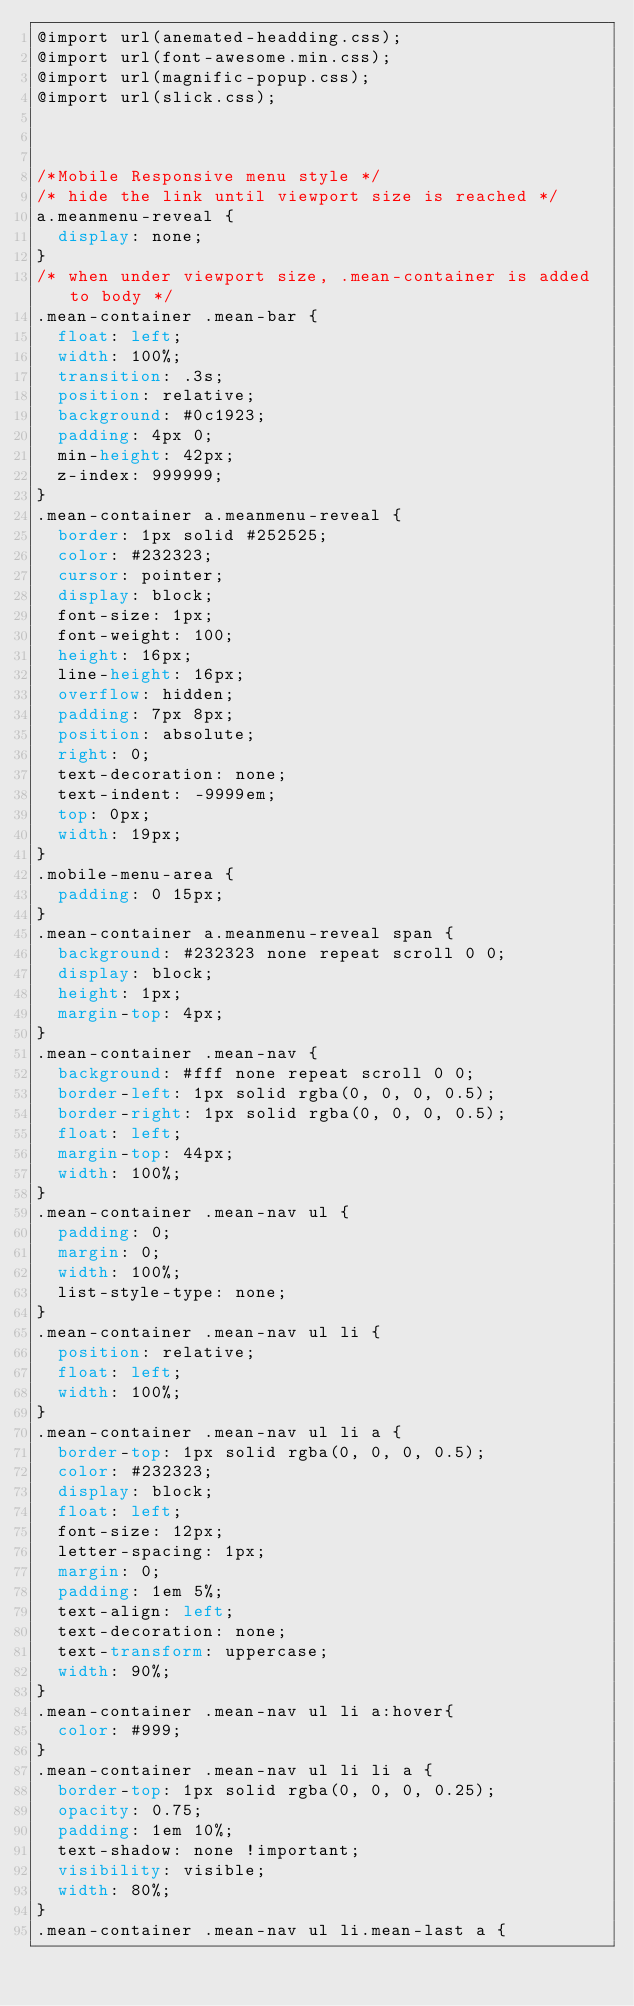Convert code to text. <code><loc_0><loc_0><loc_500><loc_500><_CSS_>@import url(anemated-headding.css);
@import url(font-awesome.min.css);
@import url(magnific-popup.css);
@import url(slick.css);



/*Mobile Responsive menu style */
/* hide the link until viewport size is reached */
a.meanmenu-reveal {
	display: none;
}
/* when under viewport size, .mean-container is added to body */
.mean-container .mean-bar {
	float: left;
	width: 100%;
	transition: .3s;
	position: relative;
	background: #0c1923;
	padding: 4px 0;
	min-height: 42px;
	z-index: 999999;
}
.mean-container a.meanmenu-reveal {
  border: 1px solid #252525;
  color: #232323;
  cursor: pointer;
  display: block;
  font-size: 1px;
  font-weight: 100;
  height: 16px;
  line-height: 16px;
  overflow: hidden;
  padding: 7px 8px;
  position: absolute;
  right: 0;
  text-decoration: none;
  text-indent: -9999em;
  top: 0px;
  width: 19px;
}
.mobile-menu-area {
	padding: 0 15px;
}
.mean-container a.meanmenu-reveal span {
  background: #232323 none repeat scroll 0 0;
  display: block;
  height: 1px;
  margin-top: 4px;
}
.mean-container .mean-nav {
  background: #fff none repeat scroll 0 0;
  border-left: 1px solid rgba(0, 0, 0, 0.5);
  border-right: 1px solid rgba(0, 0, 0, 0.5);
  float: left;
  margin-top: 44px;
  width: 100%;
}
.mean-container .mean-nav ul {
	padding: 0;
	margin: 0;
	width: 100%;
	list-style-type: none;
}
.mean-container .mean-nav ul li {
	position: relative;
	float: left;
	width: 100%;
}
.mean-container .mean-nav ul li a {
  border-top: 1px solid rgba(0, 0, 0, 0.5);
  color: #232323;
  display: block;
  float: left;
  font-size: 12px;
  letter-spacing: 1px;
  margin: 0;
  padding: 1em 5%;
  text-align: left;
  text-decoration: none;
  text-transform: uppercase;
  width: 90%;
}
.mean-container .mean-nav ul li a:hover{
	color: #999;
}
.mean-container .mean-nav ul li li a {
  border-top: 1px solid rgba(0, 0, 0, 0.25);
  opacity: 0.75;
  padding: 1em 10%;
  text-shadow: none !important;
  visibility: visible;
  width: 80%;
}
.mean-container .mean-nav ul li.mean-last a {</code> 